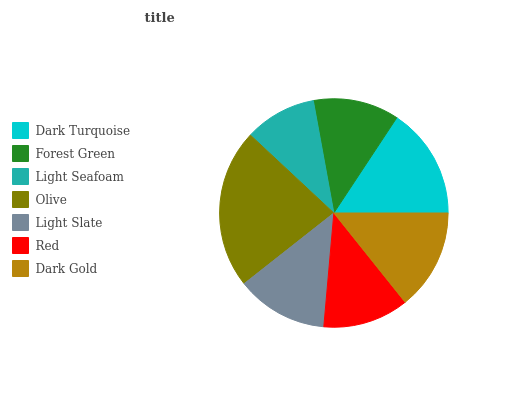Is Light Seafoam the minimum?
Answer yes or no. Yes. Is Olive the maximum?
Answer yes or no. Yes. Is Forest Green the minimum?
Answer yes or no. No. Is Forest Green the maximum?
Answer yes or no. No. Is Dark Turquoise greater than Forest Green?
Answer yes or no. Yes. Is Forest Green less than Dark Turquoise?
Answer yes or no. Yes. Is Forest Green greater than Dark Turquoise?
Answer yes or no. No. Is Dark Turquoise less than Forest Green?
Answer yes or no. No. Is Light Slate the high median?
Answer yes or no. Yes. Is Light Slate the low median?
Answer yes or no. Yes. Is Dark Gold the high median?
Answer yes or no. No. Is Forest Green the low median?
Answer yes or no. No. 